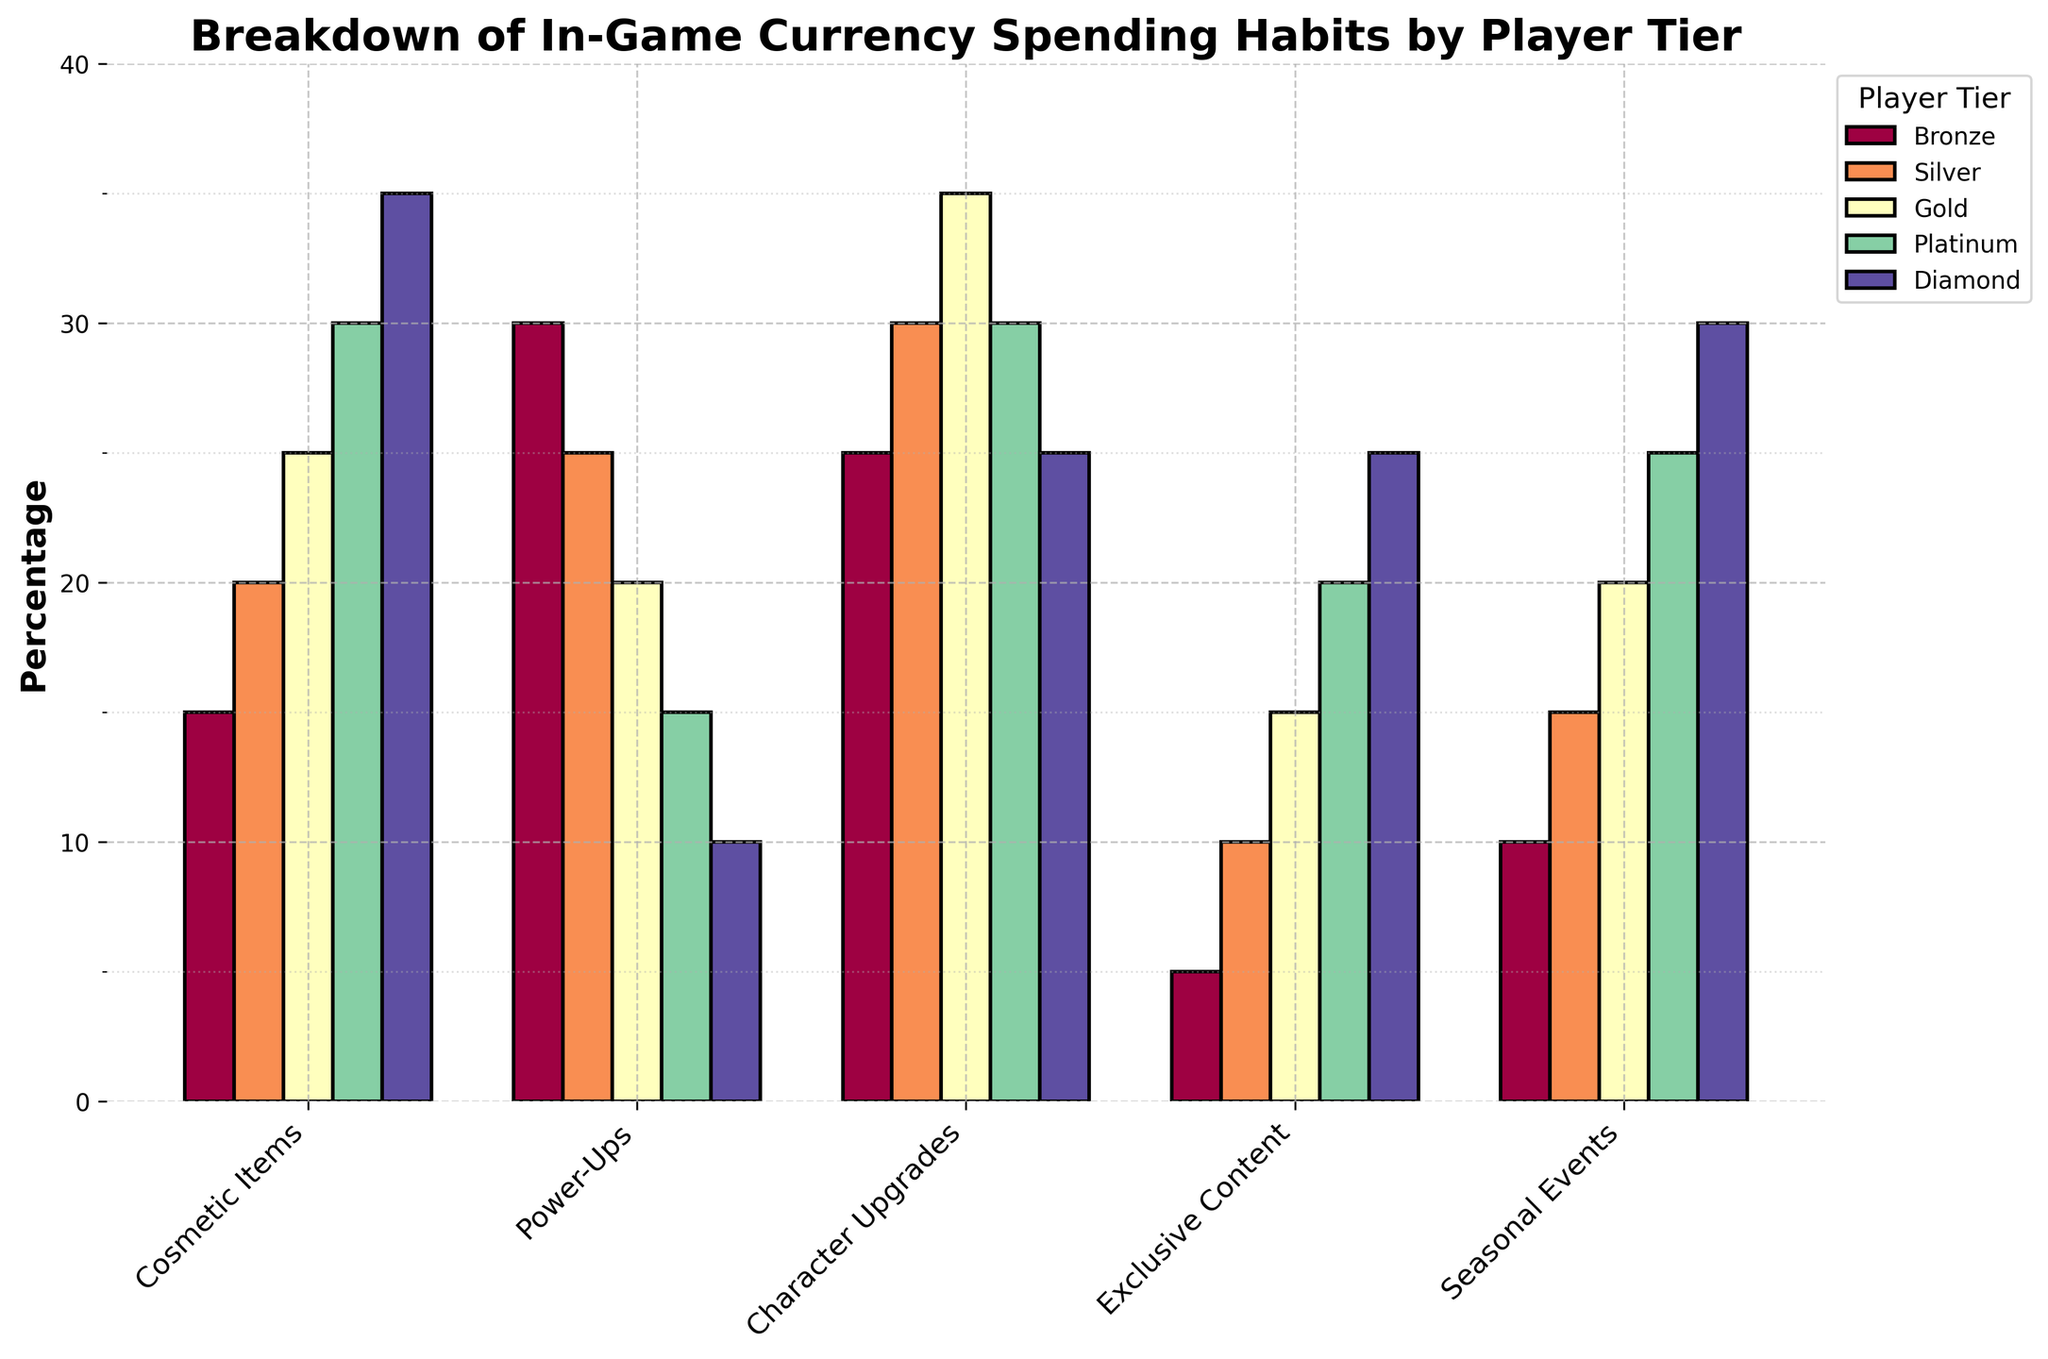What is the total percentage of in-game currency spent by Bronze tier players on Cosmetic Items and Character Upgrades? To find the total percentage, add the percentages spent on Cosmetic Items and Character Upgrades for Bronze tier: 15 + 25 = 40
Answer: 40 Which player tier spends the most on Exclusive Content, and what is the percentage? Look for the highest bar in the Exclusive Content category and identify its corresponding player tier. Diamond tier is the highest with 25%.
Answer: Diamond, 25% What is the average percentage of in-game currency spent on Power-Ups across all player tiers? Sum the percentages for Power-Ups across all tiers and divide by the number of tiers: (30 + 25 + 20 + 15 + 10) / 5 = 20
Answer: 20 Compare the spending on Seasonal Events between Silver and Gold tiers. Which tier spends more and by how much? Subtract the percentage for Gold tier from Silver tier in Seasonal Events: 20 - 15 = 5. Silver tier spends 5% more.
Answer: Silver, 5 Which category has the smallest spending percentage by any player tier, and what is it? Identify the smallest percentage across all categories and tiers. The smallest percentage is for Bronze tier in Exclusive Content: 5%.
Answer: Exclusive Content, 5 Rank the player tiers based on their spending on Character Upgrades from highest to lowest. List the tiers in descending order of their Character Upgrades percentages: 35 (Gold), 30 (Silver and Platinum), 25 (Bronze and Diamond)
Answer: Gold, Silver, Platinum, Bronze, Diamond What is the difference in spending on Cosmetic Items between the Diamond and Bronze tiers? Subtract the percentage for Bronze tier from Diamond tier for Cosmetic Items: 35 - 15 = 20
Answer: 20 Which category shows a decreasing trend in spending percentages as you go from Bronze to Diamond tier? Compare the percentages of each category from Bronze to Diamond. Power-Ups show a consistent decrease: 30 > 25 > 20 > 15 > 10
Answer: Power-Ups What is the percentage difference between the maximum and minimum spending percentages in Seasonal Events? Find the maximum and minimum percentages in Seasonal Events, which are 30 (Diamond) and 10 (Bronze). Then calculate the difference: 30 - 10 = 20
Answer: 20 Which player tier has the most evenly distributed spending across all categories? Calculate the standard deviation for each player's spending across categories. Platinum tier has percentages relatively close to each other: 30, 15, 30, 20, 25. This suggests a more even distribution compared to other tiers with higher variability.
Answer: Platinum 